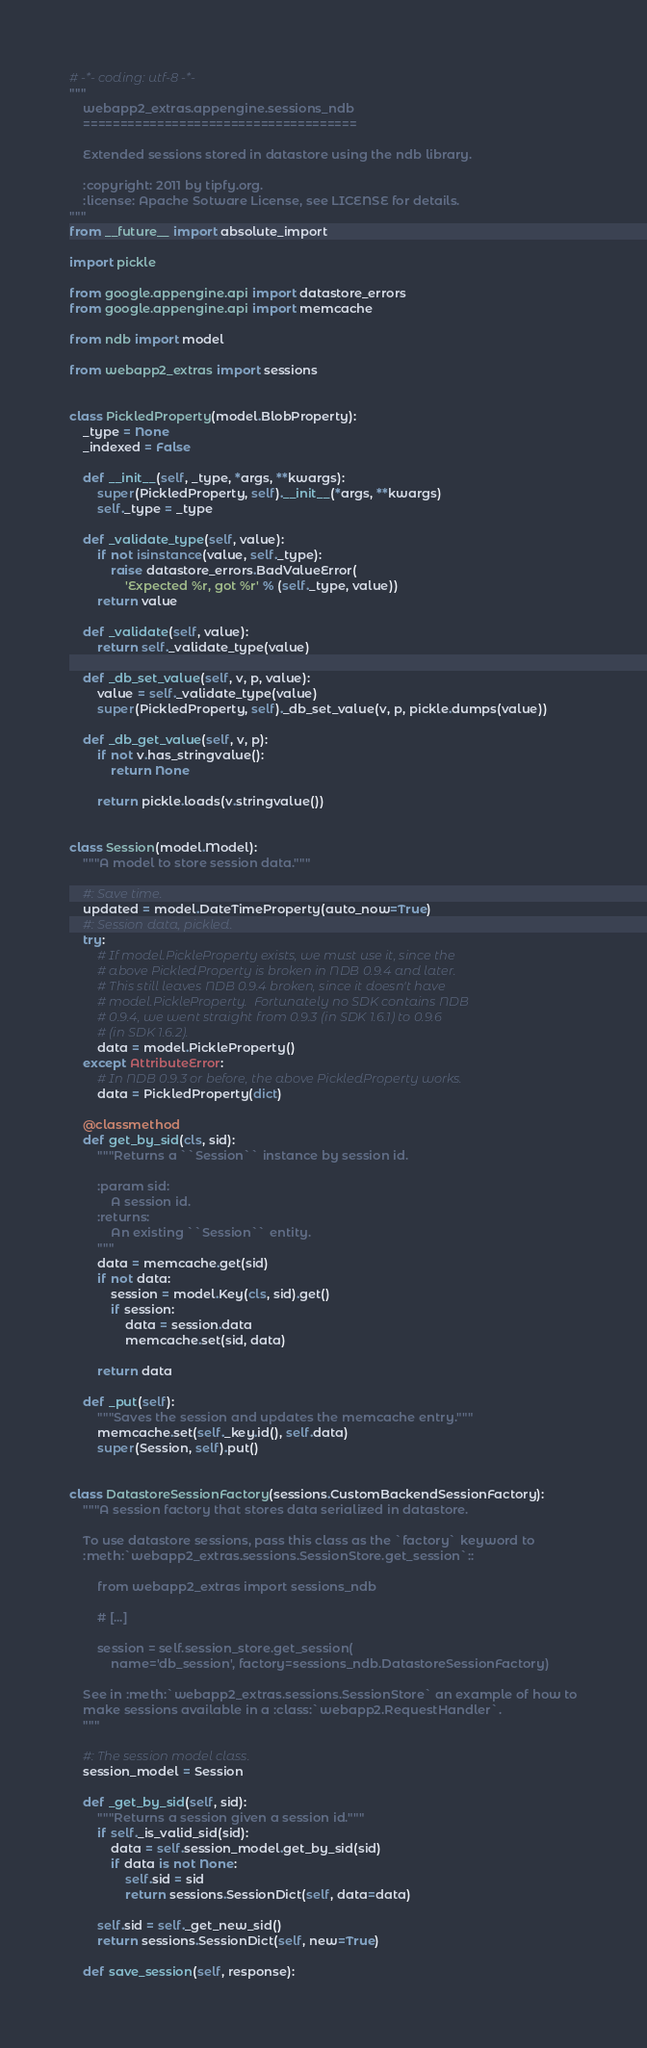Convert code to text. <code><loc_0><loc_0><loc_500><loc_500><_Python_># -*- coding: utf-8 -*-
"""
    webapp2_extras.appengine.sessions_ndb
    =====================================

    Extended sessions stored in datastore using the ndb library.

    :copyright: 2011 by tipfy.org.
    :license: Apache Sotware License, see LICENSE for details.
"""
from __future__ import absolute_import

import pickle

from google.appengine.api import datastore_errors
from google.appengine.api import memcache

from ndb import model

from webapp2_extras import sessions


class PickledProperty(model.BlobProperty):
    _type = None
    _indexed = False

    def __init__(self, _type, *args, **kwargs):
        super(PickledProperty, self).__init__(*args, **kwargs)
        self._type = _type

    def _validate_type(self, value):
        if not isinstance(value, self._type):
            raise datastore_errors.BadValueError(
                'Expected %r, got %r' % (self._type, value))
        return value

    def _validate(self, value):
        return self._validate_type(value)

    def _db_set_value(self, v, p, value):
        value = self._validate_type(value)
        super(PickledProperty, self)._db_set_value(v, p, pickle.dumps(value))

    def _db_get_value(self, v, p):
        if not v.has_stringvalue():
            return None

        return pickle.loads(v.stringvalue())


class Session(model.Model):
    """A model to store session data."""

    #: Save time.
    updated = model.DateTimeProperty(auto_now=True)
    #: Session data, pickled.
    try:
        # If model.PickleProperty exists, we must use it, since the
        # above PickledProperty is broken in NDB 0.9.4 and later.
        # This still leaves NDB 0.9.4 broken, since it doesn't have
        # model.PickleProperty.  Fortunately no SDK contains NDB
        # 0.9.4, we went straight from 0.9.3 (in SDK 1.6.1) to 0.9.6
        # (in SDK 1.6.2).
        data = model.PickleProperty()
    except AttributeError:
        # In NDB 0.9.3 or before, the above PickledProperty works.
        data = PickledProperty(dict)

    @classmethod
    def get_by_sid(cls, sid):
        """Returns a ``Session`` instance by session id.

        :param sid:
            A session id.
        :returns:
            An existing ``Session`` entity.
        """
        data = memcache.get(sid)
        if not data:
            session = model.Key(cls, sid).get()
            if session:
                data = session.data
                memcache.set(sid, data)

        return data

    def _put(self):
        """Saves the session and updates the memcache entry."""
        memcache.set(self._key.id(), self.data)
        super(Session, self).put()


class DatastoreSessionFactory(sessions.CustomBackendSessionFactory):
    """A session factory that stores data serialized in datastore.

    To use datastore sessions, pass this class as the `factory` keyword to
    :meth:`webapp2_extras.sessions.SessionStore.get_session`::

        from webapp2_extras import sessions_ndb

        # [...]

        session = self.session_store.get_session(
            name='db_session', factory=sessions_ndb.DatastoreSessionFactory)

    See in :meth:`webapp2_extras.sessions.SessionStore` an example of how to
    make sessions available in a :class:`webapp2.RequestHandler`.
    """

    #: The session model class.
    session_model = Session

    def _get_by_sid(self, sid):
        """Returns a session given a session id."""
        if self._is_valid_sid(sid):
            data = self.session_model.get_by_sid(sid)
            if data is not None:
                self.sid = sid
                return sessions.SessionDict(self, data=data)

        self.sid = self._get_new_sid()
        return sessions.SessionDict(self, new=True)

    def save_session(self, response):</code> 